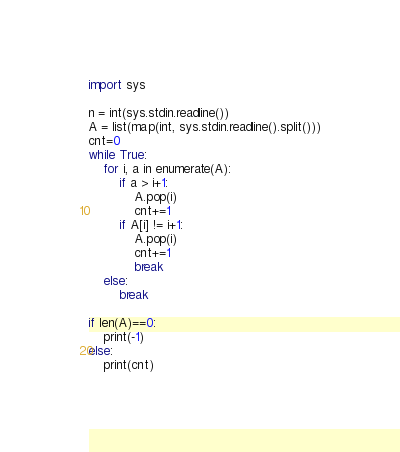Convert code to text. <code><loc_0><loc_0><loc_500><loc_500><_Python_>import sys

n = int(sys.stdin.readline())
A = list(map(int, sys.stdin.readline().split()))
cnt=0
while True:
    for i, a in enumerate(A):
        if a > i+1:
            A.pop(i)
            cnt+=1
        if A[i] != i+1:
            A.pop(i)
            cnt+=1
            break
    else:
        break

if len(A)==0:
    print(-1)
else:
    print(cnt)</code> 